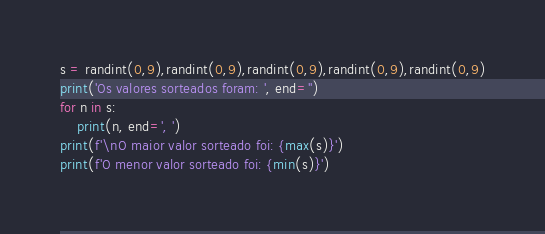Convert code to text. <code><loc_0><loc_0><loc_500><loc_500><_Python_>s = randint(0,9),randint(0,9),randint(0,9),randint(0,9),randint(0,9)
print('Os valores sorteados foram: ', end='')
for n in s:
    print(n, end=', ')
print(f'\nO maior valor sorteado foi: {max(s)}')
print(f'O menor valor sorteado foi: {min(s)}')</code> 